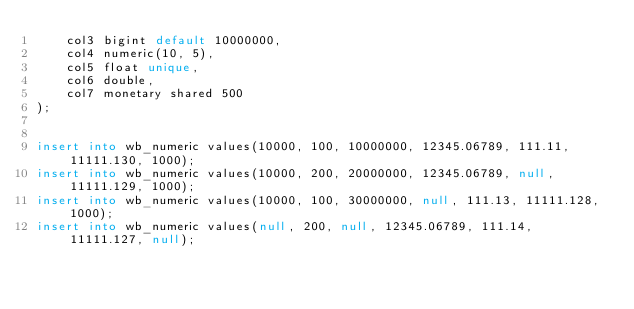Convert code to text. <code><loc_0><loc_0><loc_500><loc_500><_SQL_>	col3 bigint default 10000000,
	col4 numeric(10, 5),
	col5 float unique,
	col6 double,
	col7 monetary shared 500
);


insert into wb_numeric values(10000, 100, 10000000, 12345.06789, 111.11, 11111.130, 1000);
insert into wb_numeric values(10000, 200, 20000000, 12345.06789, null, 11111.129, 1000);
insert into wb_numeric values(10000, 100, 30000000, null, 111.13, 11111.128, 1000);
insert into wb_numeric values(null, 200, null, 12345.06789, 111.14, 11111.127, null);</code> 